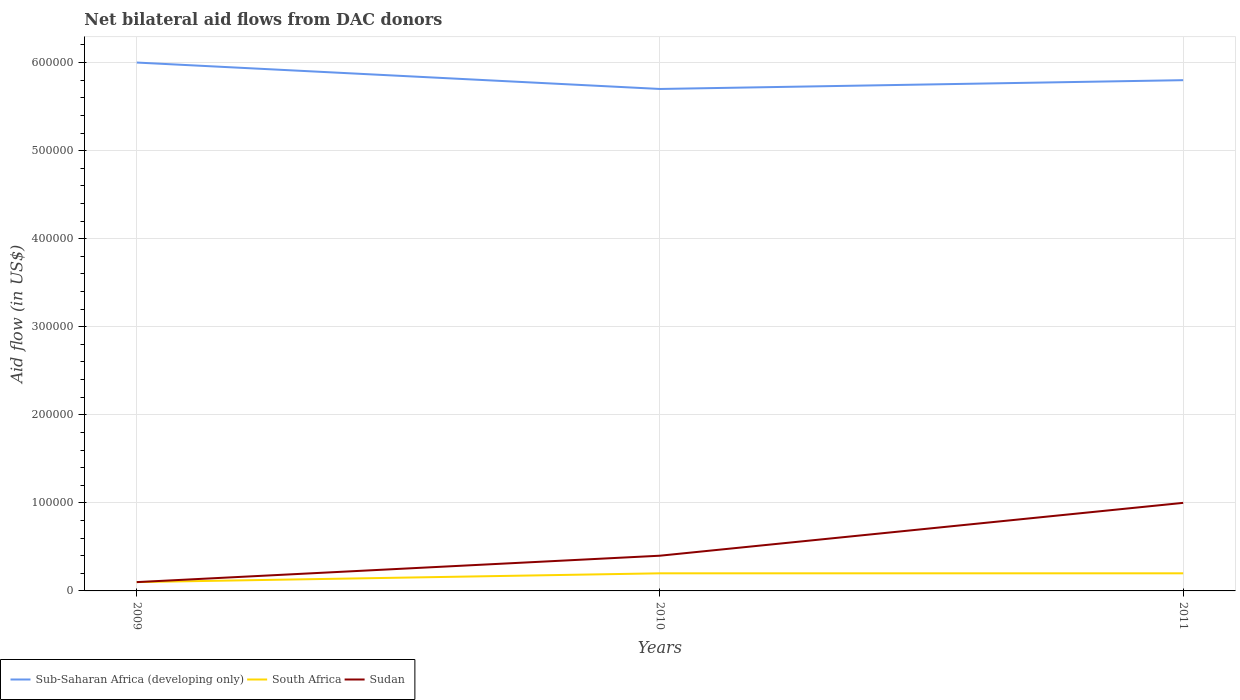How many different coloured lines are there?
Give a very brief answer. 3. Does the line corresponding to South Africa intersect with the line corresponding to Sudan?
Give a very brief answer. Yes. Across all years, what is the maximum net bilateral aid flow in Sub-Saharan Africa (developing only)?
Your answer should be compact. 5.70e+05. What is the difference between the highest and the second highest net bilateral aid flow in South Africa?
Provide a succinct answer. 10000. What is the difference between the highest and the lowest net bilateral aid flow in Sub-Saharan Africa (developing only)?
Offer a very short reply. 1. Is the net bilateral aid flow in Sudan strictly greater than the net bilateral aid flow in South Africa over the years?
Ensure brevity in your answer.  No. How many lines are there?
Offer a very short reply. 3. How many years are there in the graph?
Offer a terse response. 3. What is the difference between two consecutive major ticks on the Y-axis?
Your response must be concise. 1.00e+05. Where does the legend appear in the graph?
Your response must be concise. Bottom left. How many legend labels are there?
Your response must be concise. 3. How are the legend labels stacked?
Offer a terse response. Horizontal. What is the title of the graph?
Give a very brief answer. Net bilateral aid flows from DAC donors. Does "Grenada" appear as one of the legend labels in the graph?
Your answer should be very brief. No. What is the label or title of the Y-axis?
Keep it short and to the point. Aid flow (in US$). What is the Aid flow (in US$) of Sub-Saharan Africa (developing only) in 2009?
Ensure brevity in your answer.  6.00e+05. What is the Aid flow (in US$) of South Africa in 2009?
Offer a very short reply. 10000. What is the Aid flow (in US$) in Sudan in 2009?
Give a very brief answer. 10000. What is the Aid flow (in US$) of Sub-Saharan Africa (developing only) in 2010?
Your response must be concise. 5.70e+05. What is the Aid flow (in US$) of South Africa in 2010?
Ensure brevity in your answer.  2.00e+04. What is the Aid flow (in US$) of Sudan in 2010?
Give a very brief answer. 4.00e+04. What is the Aid flow (in US$) of Sub-Saharan Africa (developing only) in 2011?
Provide a short and direct response. 5.80e+05. What is the Aid flow (in US$) of South Africa in 2011?
Keep it short and to the point. 2.00e+04. What is the Aid flow (in US$) in Sudan in 2011?
Your answer should be very brief. 1.00e+05. Across all years, what is the maximum Aid flow (in US$) of South Africa?
Offer a very short reply. 2.00e+04. Across all years, what is the minimum Aid flow (in US$) in Sub-Saharan Africa (developing only)?
Give a very brief answer. 5.70e+05. What is the total Aid flow (in US$) of Sub-Saharan Africa (developing only) in the graph?
Give a very brief answer. 1.75e+06. What is the total Aid flow (in US$) in South Africa in the graph?
Ensure brevity in your answer.  5.00e+04. What is the total Aid flow (in US$) of Sudan in the graph?
Provide a short and direct response. 1.50e+05. What is the difference between the Aid flow (in US$) of South Africa in 2009 and that in 2010?
Your answer should be very brief. -10000. What is the difference between the Aid flow (in US$) of South Africa in 2009 and that in 2011?
Your answer should be compact. -10000. What is the difference between the Aid flow (in US$) in Sudan in 2009 and that in 2011?
Ensure brevity in your answer.  -9.00e+04. What is the difference between the Aid flow (in US$) in Sub-Saharan Africa (developing only) in 2010 and that in 2011?
Give a very brief answer. -10000. What is the difference between the Aid flow (in US$) of Sub-Saharan Africa (developing only) in 2009 and the Aid flow (in US$) of South Africa in 2010?
Your answer should be compact. 5.80e+05. What is the difference between the Aid flow (in US$) of Sub-Saharan Africa (developing only) in 2009 and the Aid flow (in US$) of Sudan in 2010?
Your answer should be very brief. 5.60e+05. What is the difference between the Aid flow (in US$) of Sub-Saharan Africa (developing only) in 2009 and the Aid flow (in US$) of South Africa in 2011?
Keep it short and to the point. 5.80e+05. What is the difference between the Aid flow (in US$) of Sub-Saharan Africa (developing only) in 2009 and the Aid flow (in US$) of Sudan in 2011?
Provide a short and direct response. 5.00e+05. What is the difference between the Aid flow (in US$) in South Africa in 2009 and the Aid flow (in US$) in Sudan in 2011?
Your answer should be compact. -9.00e+04. What is the difference between the Aid flow (in US$) in South Africa in 2010 and the Aid flow (in US$) in Sudan in 2011?
Ensure brevity in your answer.  -8.00e+04. What is the average Aid flow (in US$) in Sub-Saharan Africa (developing only) per year?
Provide a short and direct response. 5.83e+05. What is the average Aid flow (in US$) in South Africa per year?
Ensure brevity in your answer.  1.67e+04. What is the average Aid flow (in US$) of Sudan per year?
Provide a succinct answer. 5.00e+04. In the year 2009, what is the difference between the Aid flow (in US$) of Sub-Saharan Africa (developing only) and Aid flow (in US$) of South Africa?
Offer a terse response. 5.90e+05. In the year 2009, what is the difference between the Aid flow (in US$) of Sub-Saharan Africa (developing only) and Aid flow (in US$) of Sudan?
Provide a short and direct response. 5.90e+05. In the year 2009, what is the difference between the Aid flow (in US$) of South Africa and Aid flow (in US$) of Sudan?
Your answer should be very brief. 0. In the year 2010, what is the difference between the Aid flow (in US$) in Sub-Saharan Africa (developing only) and Aid flow (in US$) in Sudan?
Provide a short and direct response. 5.30e+05. In the year 2011, what is the difference between the Aid flow (in US$) in Sub-Saharan Africa (developing only) and Aid flow (in US$) in South Africa?
Provide a succinct answer. 5.60e+05. In the year 2011, what is the difference between the Aid flow (in US$) in Sub-Saharan Africa (developing only) and Aid flow (in US$) in Sudan?
Offer a very short reply. 4.80e+05. In the year 2011, what is the difference between the Aid flow (in US$) in South Africa and Aid flow (in US$) in Sudan?
Give a very brief answer. -8.00e+04. What is the ratio of the Aid flow (in US$) of Sub-Saharan Africa (developing only) in 2009 to that in 2010?
Keep it short and to the point. 1.05. What is the ratio of the Aid flow (in US$) in Sub-Saharan Africa (developing only) in 2009 to that in 2011?
Offer a terse response. 1.03. What is the ratio of the Aid flow (in US$) of South Africa in 2009 to that in 2011?
Your answer should be very brief. 0.5. What is the ratio of the Aid flow (in US$) of Sub-Saharan Africa (developing only) in 2010 to that in 2011?
Give a very brief answer. 0.98. What is the ratio of the Aid flow (in US$) in South Africa in 2010 to that in 2011?
Your response must be concise. 1. What is the ratio of the Aid flow (in US$) in Sudan in 2010 to that in 2011?
Provide a short and direct response. 0.4. What is the difference between the highest and the second highest Aid flow (in US$) of Sudan?
Ensure brevity in your answer.  6.00e+04. 